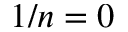Convert formula to latex. <formula><loc_0><loc_0><loc_500><loc_500>1 / n = 0</formula> 